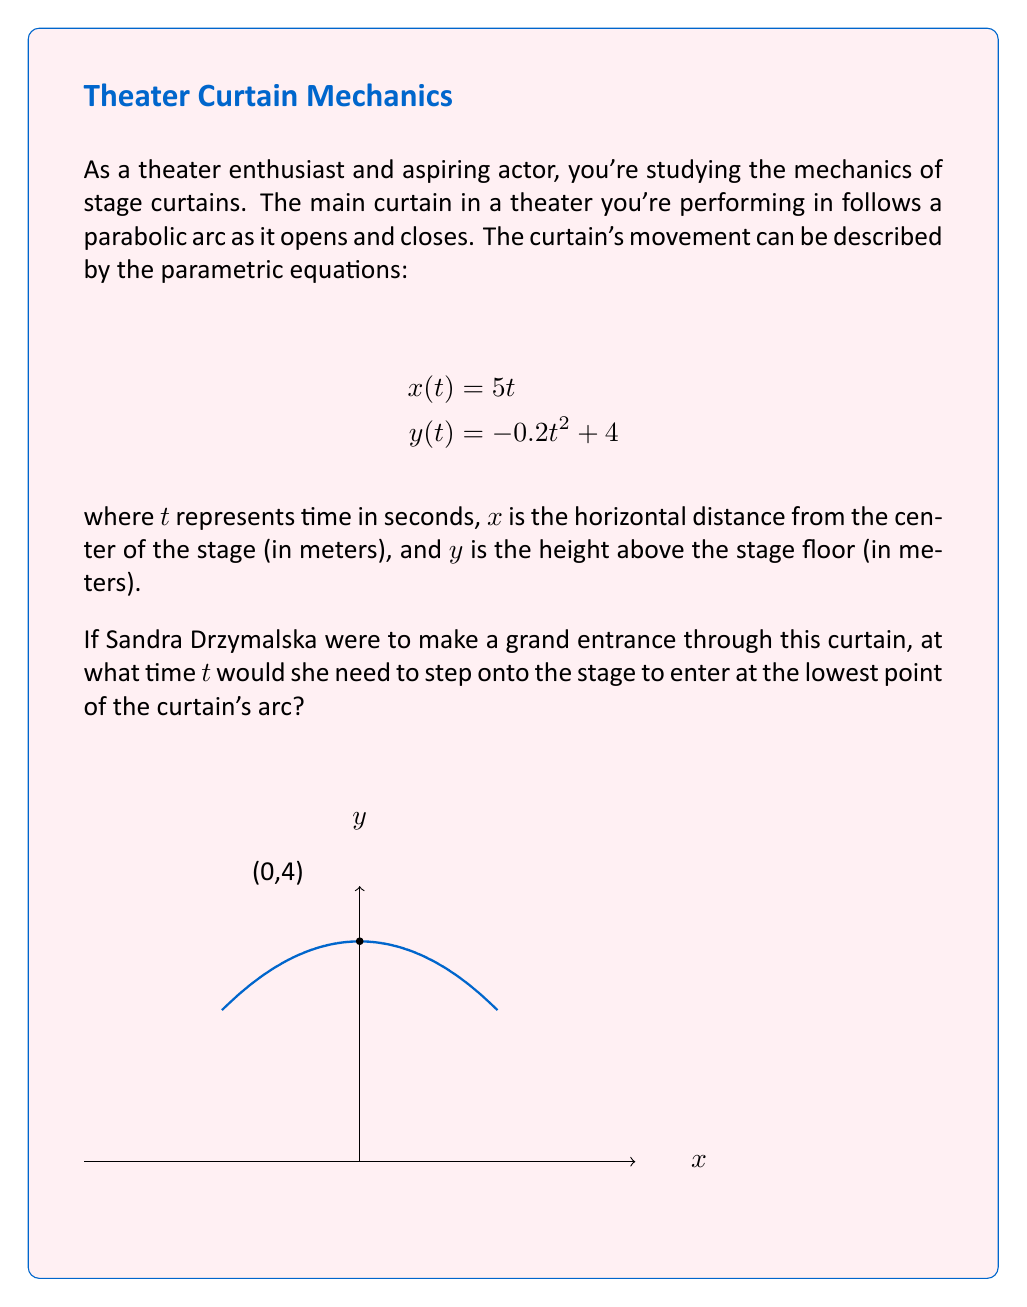Teach me how to tackle this problem. Let's approach this step-by-step:

1) The lowest point of the parabolic arc will occur when $y(t)$ is at its minimum value.

2) To find the minimum of $y(t)$, we need to find where its derivative equals zero:

   $$\frac{dy}{dt} = -0.4t$$

3) Set this equal to zero and solve for $t$:

   $$-0.4t = 0$$
   $$t = 0$$

4) We can confirm this is a minimum (not a maximum) by checking the second derivative:

   $$\frac{d^2y}{dt^2} = -0.4$$

   Since this is negative, we confirm it's a minimum.

5) When $t = 0$, we can calculate the corresponding $x$ and $y$ values:

   $$x(0) = 5(0) = 0$$
   $$y(0) = -0.2(0)^2 + 4 = 4$$

6) Therefore, the lowest point of the curtain is at (0, 4), which corresponds to the center of the stage at a height of 4 meters.
Answer: $t = 0$ seconds 